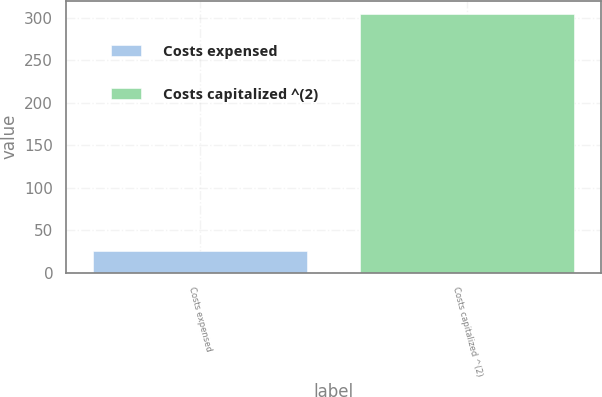Convert chart to OTSL. <chart><loc_0><loc_0><loc_500><loc_500><bar_chart><fcel>Costs expensed<fcel>Costs capitalized ^(2)<nl><fcel>26<fcel>305<nl></chart> 